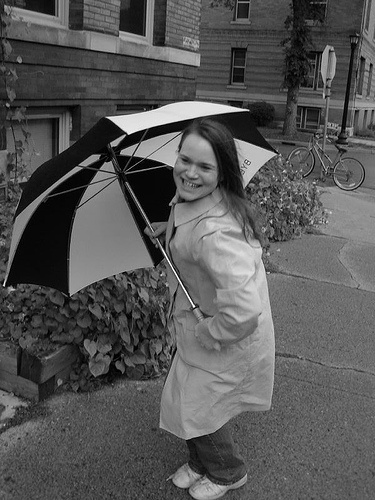Describe the objects in this image and their specific colors. I can see people in black, darkgray, gray, and lightgray tones, umbrella in black, gray, and gainsboro tones, bicycle in black, gray, darkgray, and lightgray tones, and stop sign in dimgray, darkgray, and black tones in this image. 